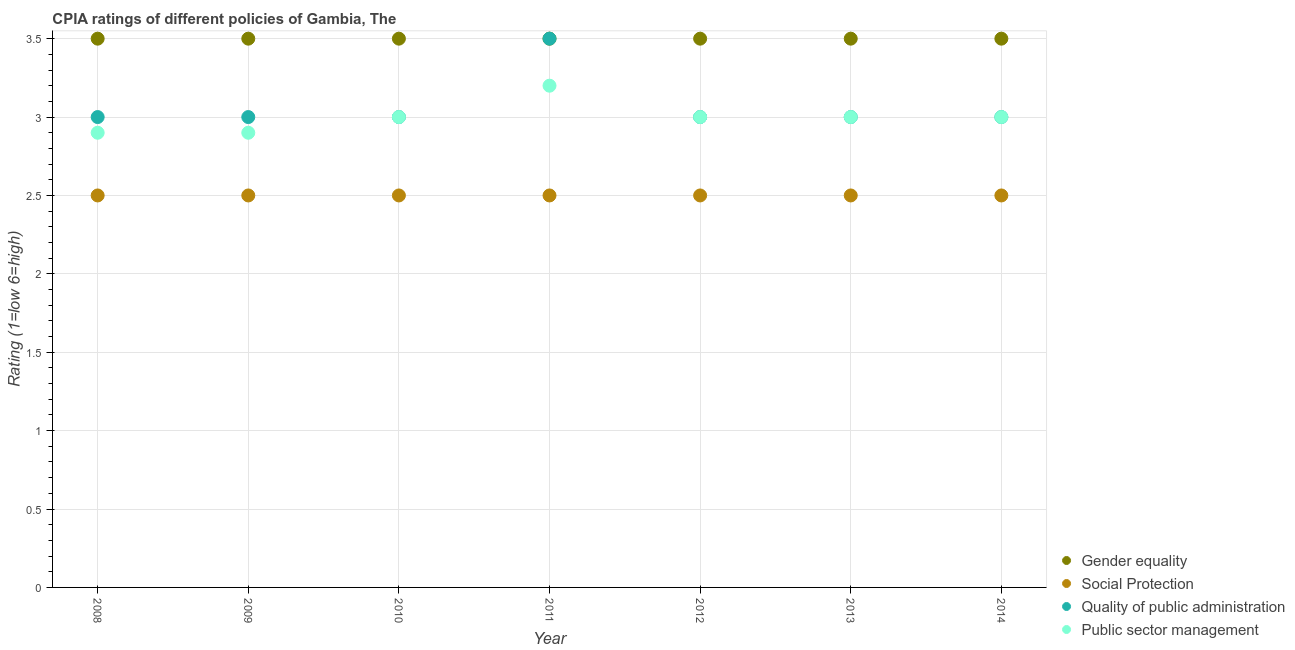How many different coloured dotlines are there?
Offer a terse response. 4. Across all years, what is the maximum cpia rating of gender equality?
Your response must be concise. 3.5. Across all years, what is the minimum cpia rating of public sector management?
Give a very brief answer. 2.9. In which year was the cpia rating of gender equality maximum?
Ensure brevity in your answer.  2008. In which year was the cpia rating of public sector management minimum?
Your response must be concise. 2008. What is the difference between the cpia rating of public sector management in 2012 and that in 2013?
Keep it short and to the point. 0. In how many years, is the cpia rating of quality of public administration greater than 2.7?
Your response must be concise. 7. Is the cpia rating of public sector management in 2010 less than that in 2014?
Offer a terse response. No. Is the difference between the cpia rating of social protection in 2008 and 2009 greater than the difference between the cpia rating of quality of public administration in 2008 and 2009?
Provide a short and direct response. No. What is the difference between the highest and the second highest cpia rating of gender equality?
Your answer should be compact. 0. What is the difference between the highest and the lowest cpia rating of quality of public administration?
Provide a succinct answer. 0.5. Is it the case that in every year, the sum of the cpia rating of social protection and cpia rating of quality of public administration is greater than the sum of cpia rating of gender equality and cpia rating of public sector management?
Make the answer very short. No. Is the cpia rating of public sector management strictly greater than the cpia rating of social protection over the years?
Your answer should be very brief. Yes. How many years are there in the graph?
Your response must be concise. 7. What is the difference between two consecutive major ticks on the Y-axis?
Your answer should be very brief. 0.5. Are the values on the major ticks of Y-axis written in scientific E-notation?
Your answer should be compact. No. Does the graph contain any zero values?
Keep it short and to the point. No. Where does the legend appear in the graph?
Your answer should be compact. Bottom right. How many legend labels are there?
Give a very brief answer. 4. What is the title of the graph?
Make the answer very short. CPIA ratings of different policies of Gambia, The. Does "Japan" appear as one of the legend labels in the graph?
Make the answer very short. No. What is the label or title of the X-axis?
Your answer should be compact. Year. What is the Rating (1=low 6=high) of Gender equality in 2008?
Provide a succinct answer. 3.5. What is the Rating (1=low 6=high) of Quality of public administration in 2008?
Your answer should be compact. 3. What is the Rating (1=low 6=high) of Social Protection in 2009?
Give a very brief answer. 2.5. What is the Rating (1=low 6=high) in Quality of public administration in 2009?
Offer a very short reply. 3. What is the Rating (1=low 6=high) of Public sector management in 2009?
Provide a succinct answer. 2.9. What is the Rating (1=low 6=high) in Social Protection in 2010?
Make the answer very short. 2.5. What is the Rating (1=low 6=high) of Quality of public administration in 2010?
Your answer should be very brief. 3. What is the Rating (1=low 6=high) of Social Protection in 2011?
Your answer should be very brief. 2.5. What is the Rating (1=low 6=high) of Public sector management in 2011?
Give a very brief answer. 3.2. What is the Rating (1=low 6=high) in Gender equality in 2012?
Keep it short and to the point. 3.5. What is the Rating (1=low 6=high) of Quality of public administration in 2012?
Offer a terse response. 3. What is the Rating (1=low 6=high) in Public sector management in 2012?
Make the answer very short. 3. What is the Rating (1=low 6=high) in Quality of public administration in 2013?
Provide a short and direct response. 3. What is the Rating (1=low 6=high) in Public sector management in 2014?
Make the answer very short. 3. Across all years, what is the maximum Rating (1=low 6=high) of Gender equality?
Make the answer very short. 3.5. Across all years, what is the maximum Rating (1=low 6=high) of Social Protection?
Make the answer very short. 2.5. Across all years, what is the maximum Rating (1=low 6=high) of Quality of public administration?
Make the answer very short. 3.5. Across all years, what is the maximum Rating (1=low 6=high) in Public sector management?
Make the answer very short. 3.2. Across all years, what is the minimum Rating (1=low 6=high) in Social Protection?
Make the answer very short. 2.5. Across all years, what is the minimum Rating (1=low 6=high) of Quality of public administration?
Ensure brevity in your answer.  3. Across all years, what is the minimum Rating (1=low 6=high) in Public sector management?
Keep it short and to the point. 2.9. What is the total Rating (1=low 6=high) in Gender equality in the graph?
Offer a very short reply. 24.5. What is the total Rating (1=low 6=high) in Social Protection in the graph?
Your response must be concise. 17.5. What is the total Rating (1=low 6=high) of Quality of public administration in the graph?
Offer a very short reply. 21.5. What is the total Rating (1=low 6=high) of Public sector management in the graph?
Your answer should be very brief. 21. What is the difference between the Rating (1=low 6=high) in Social Protection in 2008 and that in 2009?
Offer a very short reply. 0. What is the difference between the Rating (1=low 6=high) in Quality of public administration in 2008 and that in 2009?
Provide a short and direct response. 0. What is the difference between the Rating (1=low 6=high) in Public sector management in 2008 and that in 2009?
Offer a terse response. 0. What is the difference between the Rating (1=low 6=high) in Public sector management in 2008 and that in 2010?
Provide a succinct answer. -0.1. What is the difference between the Rating (1=low 6=high) of Social Protection in 2008 and that in 2011?
Make the answer very short. 0. What is the difference between the Rating (1=low 6=high) of Quality of public administration in 2008 and that in 2011?
Offer a terse response. -0.5. What is the difference between the Rating (1=low 6=high) of Gender equality in 2008 and that in 2012?
Ensure brevity in your answer.  0. What is the difference between the Rating (1=low 6=high) in Quality of public administration in 2008 and that in 2012?
Provide a short and direct response. 0. What is the difference between the Rating (1=low 6=high) of Public sector management in 2008 and that in 2012?
Ensure brevity in your answer.  -0.1. What is the difference between the Rating (1=low 6=high) in Gender equality in 2008 and that in 2013?
Provide a succinct answer. 0. What is the difference between the Rating (1=low 6=high) of Quality of public administration in 2008 and that in 2014?
Offer a terse response. 0. What is the difference between the Rating (1=low 6=high) in Public sector management in 2008 and that in 2014?
Keep it short and to the point. -0.1. What is the difference between the Rating (1=low 6=high) in Gender equality in 2009 and that in 2010?
Provide a succinct answer. 0. What is the difference between the Rating (1=low 6=high) in Social Protection in 2009 and that in 2011?
Keep it short and to the point. 0. What is the difference between the Rating (1=low 6=high) of Quality of public administration in 2009 and that in 2012?
Offer a terse response. 0. What is the difference between the Rating (1=low 6=high) of Public sector management in 2009 and that in 2012?
Your answer should be compact. -0.1. What is the difference between the Rating (1=low 6=high) in Gender equality in 2009 and that in 2013?
Give a very brief answer. 0. What is the difference between the Rating (1=low 6=high) in Quality of public administration in 2009 and that in 2013?
Your response must be concise. 0. What is the difference between the Rating (1=low 6=high) in Social Protection in 2009 and that in 2014?
Offer a terse response. 0. What is the difference between the Rating (1=low 6=high) of Quality of public administration in 2009 and that in 2014?
Offer a very short reply. 0. What is the difference between the Rating (1=low 6=high) of Social Protection in 2010 and that in 2011?
Keep it short and to the point. 0. What is the difference between the Rating (1=low 6=high) in Gender equality in 2010 and that in 2012?
Offer a terse response. 0. What is the difference between the Rating (1=low 6=high) of Gender equality in 2010 and that in 2013?
Provide a succinct answer. 0. What is the difference between the Rating (1=low 6=high) in Quality of public administration in 2010 and that in 2013?
Offer a very short reply. 0. What is the difference between the Rating (1=low 6=high) of Gender equality in 2010 and that in 2014?
Keep it short and to the point. 0. What is the difference between the Rating (1=low 6=high) in Social Protection in 2010 and that in 2014?
Ensure brevity in your answer.  0. What is the difference between the Rating (1=low 6=high) in Quality of public administration in 2010 and that in 2014?
Your answer should be compact. 0. What is the difference between the Rating (1=low 6=high) in Public sector management in 2010 and that in 2014?
Ensure brevity in your answer.  0. What is the difference between the Rating (1=low 6=high) of Gender equality in 2011 and that in 2012?
Give a very brief answer. 0. What is the difference between the Rating (1=low 6=high) in Quality of public administration in 2011 and that in 2012?
Your answer should be very brief. 0.5. What is the difference between the Rating (1=low 6=high) of Social Protection in 2011 and that in 2013?
Provide a succinct answer. 0. What is the difference between the Rating (1=low 6=high) of Quality of public administration in 2011 and that in 2013?
Offer a terse response. 0.5. What is the difference between the Rating (1=low 6=high) of Gender equality in 2011 and that in 2014?
Your answer should be compact. 0. What is the difference between the Rating (1=low 6=high) of Social Protection in 2011 and that in 2014?
Keep it short and to the point. 0. What is the difference between the Rating (1=low 6=high) of Public sector management in 2011 and that in 2014?
Your answer should be very brief. 0.2. What is the difference between the Rating (1=low 6=high) of Social Protection in 2012 and that in 2013?
Your answer should be very brief. 0. What is the difference between the Rating (1=low 6=high) in Gender equality in 2012 and that in 2014?
Your answer should be very brief. 0. What is the difference between the Rating (1=low 6=high) of Public sector management in 2012 and that in 2014?
Provide a short and direct response. 0. What is the difference between the Rating (1=low 6=high) in Public sector management in 2013 and that in 2014?
Your response must be concise. 0. What is the difference between the Rating (1=low 6=high) in Gender equality in 2008 and the Rating (1=low 6=high) in Social Protection in 2009?
Make the answer very short. 1. What is the difference between the Rating (1=low 6=high) in Gender equality in 2008 and the Rating (1=low 6=high) in Public sector management in 2009?
Ensure brevity in your answer.  0.6. What is the difference between the Rating (1=low 6=high) of Social Protection in 2008 and the Rating (1=low 6=high) of Public sector management in 2009?
Give a very brief answer. -0.4. What is the difference between the Rating (1=low 6=high) in Gender equality in 2008 and the Rating (1=low 6=high) in Public sector management in 2010?
Offer a very short reply. 0.5. What is the difference between the Rating (1=low 6=high) of Social Protection in 2008 and the Rating (1=low 6=high) of Quality of public administration in 2010?
Your response must be concise. -0.5. What is the difference between the Rating (1=low 6=high) of Gender equality in 2008 and the Rating (1=low 6=high) of Social Protection in 2011?
Your answer should be very brief. 1. What is the difference between the Rating (1=low 6=high) of Gender equality in 2008 and the Rating (1=low 6=high) of Quality of public administration in 2011?
Provide a short and direct response. 0. What is the difference between the Rating (1=low 6=high) of Social Protection in 2008 and the Rating (1=low 6=high) of Quality of public administration in 2011?
Offer a very short reply. -1. What is the difference between the Rating (1=low 6=high) of Quality of public administration in 2008 and the Rating (1=low 6=high) of Public sector management in 2011?
Offer a terse response. -0.2. What is the difference between the Rating (1=low 6=high) of Gender equality in 2008 and the Rating (1=low 6=high) of Quality of public administration in 2012?
Give a very brief answer. 0.5. What is the difference between the Rating (1=low 6=high) in Social Protection in 2008 and the Rating (1=low 6=high) in Quality of public administration in 2012?
Make the answer very short. -0.5. What is the difference between the Rating (1=low 6=high) in Gender equality in 2008 and the Rating (1=low 6=high) in Social Protection in 2013?
Your response must be concise. 1. What is the difference between the Rating (1=low 6=high) in Social Protection in 2008 and the Rating (1=low 6=high) in Public sector management in 2013?
Give a very brief answer. -0.5. What is the difference between the Rating (1=low 6=high) in Quality of public administration in 2008 and the Rating (1=low 6=high) in Public sector management in 2013?
Your response must be concise. 0. What is the difference between the Rating (1=low 6=high) of Gender equality in 2008 and the Rating (1=low 6=high) of Social Protection in 2014?
Your answer should be very brief. 1. What is the difference between the Rating (1=low 6=high) in Quality of public administration in 2008 and the Rating (1=low 6=high) in Public sector management in 2014?
Make the answer very short. 0. What is the difference between the Rating (1=low 6=high) of Gender equality in 2009 and the Rating (1=low 6=high) of Social Protection in 2010?
Provide a succinct answer. 1. What is the difference between the Rating (1=low 6=high) of Gender equality in 2009 and the Rating (1=low 6=high) of Public sector management in 2010?
Provide a succinct answer. 0.5. What is the difference between the Rating (1=low 6=high) of Social Protection in 2009 and the Rating (1=low 6=high) of Quality of public administration in 2010?
Offer a terse response. -0.5. What is the difference between the Rating (1=low 6=high) in Quality of public administration in 2009 and the Rating (1=low 6=high) in Public sector management in 2010?
Your answer should be very brief. 0. What is the difference between the Rating (1=low 6=high) in Gender equality in 2009 and the Rating (1=low 6=high) in Quality of public administration in 2011?
Make the answer very short. 0. What is the difference between the Rating (1=low 6=high) in Social Protection in 2009 and the Rating (1=low 6=high) in Public sector management in 2011?
Provide a succinct answer. -0.7. What is the difference between the Rating (1=low 6=high) in Gender equality in 2009 and the Rating (1=low 6=high) in Social Protection in 2012?
Your response must be concise. 1. What is the difference between the Rating (1=low 6=high) of Gender equality in 2009 and the Rating (1=low 6=high) of Quality of public administration in 2012?
Your answer should be very brief. 0.5. What is the difference between the Rating (1=low 6=high) of Social Protection in 2009 and the Rating (1=low 6=high) of Quality of public administration in 2012?
Ensure brevity in your answer.  -0.5. What is the difference between the Rating (1=low 6=high) in Gender equality in 2009 and the Rating (1=low 6=high) in Quality of public administration in 2013?
Make the answer very short. 0.5. What is the difference between the Rating (1=low 6=high) in Gender equality in 2009 and the Rating (1=low 6=high) in Public sector management in 2013?
Provide a succinct answer. 0.5. What is the difference between the Rating (1=low 6=high) in Social Protection in 2009 and the Rating (1=low 6=high) in Quality of public administration in 2013?
Make the answer very short. -0.5. What is the difference between the Rating (1=low 6=high) of Social Protection in 2009 and the Rating (1=low 6=high) of Public sector management in 2013?
Ensure brevity in your answer.  -0.5. What is the difference between the Rating (1=low 6=high) of Gender equality in 2009 and the Rating (1=low 6=high) of Quality of public administration in 2014?
Give a very brief answer. 0.5. What is the difference between the Rating (1=low 6=high) in Gender equality in 2009 and the Rating (1=low 6=high) in Public sector management in 2014?
Your answer should be compact. 0.5. What is the difference between the Rating (1=low 6=high) of Social Protection in 2009 and the Rating (1=low 6=high) of Quality of public administration in 2014?
Offer a terse response. -0.5. What is the difference between the Rating (1=low 6=high) of Quality of public administration in 2009 and the Rating (1=low 6=high) of Public sector management in 2014?
Your response must be concise. 0. What is the difference between the Rating (1=low 6=high) of Gender equality in 2010 and the Rating (1=low 6=high) of Social Protection in 2011?
Provide a short and direct response. 1. What is the difference between the Rating (1=low 6=high) in Gender equality in 2010 and the Rating (1=low 6=high) in Public sector management in 2011?
Offer a very short reply. 0.3. What is the difference between the Rating (1=low 6=high) of Social Protection in 2010 and the Rating (1=low 6=high) of Quality of public administration in 2011?
Offer a very short reply. -1. What is the difference between the Rating (1=low 6=high) of Social Protection in 2010 and the Rating (1=low 6=high) of Public sector management in 2011?
Provide a succinct answer. -0.7. What is the difference between the Rating (1=low 6=high) in Gender equality in 2010 and the Rating (1=low 6=high) in Social Protection in 2012?
Offer a terse response. 1. What is the difference between the Rating (1=low 6=high) in Gender equality in 2010 and the Rating (1=low 6=high) in Public sector management in 2012?
Keep it short and to the point. 0.5. What is the difference between the Rating (1=low 6=high) in Social Protection in 2010 and the Rating (1=low 6=high) in Public sector management in 2012?
Give a very brief answer. -0.5. What is the difference between the Rating (1=low 6=high) of Social Protection in 2010 and the Rating (1=low 6=high) of Quality of public administration in 2013?
Provide a short and direct response. -0.5. What is the difference between the Rating (1=low 6=high) of Quality of public administration in 2010 and the Rating (1=low 6=high) of Public sector management in 2013?
Your answer should be very brief. 0. What is the difference between the Rating (1=low 6=high) of Gender equality in 2010 and the Rating (1=low 6=high) of Quality of public administration in 2014?
Keep it short and to the point. 0.5. What is the difference between the Rating (1=low 6=high) of Gender equality in 2010 and the Rating (1=low 6=high) of Public sector management in 2014?
Give a very brief answer. 0.5. What is the difference between the Rating (1=low 6=high) of Social Protection in 2010 and the Rating (1=low 6=high) of Public sector management in 2014?
Provide a short and direct response. -0.5. What is the difference between the Rating (1=low 6=high) of Gender equality in 2011 and the Rating (1=low 6=high) of Social Protection in 2012?
Your answer should be compact. 1. What is the difference between the Rating (1=low 6=high) in Social Protection in 2011 and the Rating (1=low 6=high) in Public sector management in 2012?
Give a very brief answer. -0.5. What is the difference between the Rating (1=low 6=high) of Quality of public administration in 2011 and the Rating (1=low 6=high) of Public sector management in 2012?
Ensure brevity in your answer.  0.5. What is the difference between the Rating (1=low 6=high) in Gender equality in 2011 and the Rating (1=low 6=high) in Quality of public administration in 2013?
Provide a short and direct response. 0.5. What is the difference between the Rating (1=low 6=high) in Social Protection in 2011 and the Rating (1=low 6=high) in Quality of public administration in 2013?
Your answer should be compact. -0.5. What is the difference between the Rating (1=low 6=high) of Social Protection in 2011 and the Rating (1=low 6=high) of Public sector management in 2013?
Your answer should be compact. -0.5. What is the difference between the Rating (1=low 6=high) of Gender equality in 2011 and the Rating (1=low 6=high) of Social Protection in 2014?
Offer a terse response. 1. What is the difference between the Rating (1=low 6=high) of Social Protection in 2011 and the Rating (1=low 6=high) of Quality of public administration in 2014?
Ensure brevity in your answer.  -0.5. What is the difference between the Rating (1=low 6=high) in Gender equality in 2012 and the Rating (1=low 6=high) in Quality of public administration in 2013?
Your answer should be very brief. 0.5. What is the difference between the Rating (1=low 6=high) of Social Protection in 2012 and the Rating (1=low 6=high) of Quality of public administration in 2013?
Your response must be concise. -0.5. What is the difference between the Rating (1=low 6=high) of Gender equality in 2012 and the Rating (1=low 6=high) of Social Protection in 2014?
Your answer should be compact. 1. What is the difference between the Rating (1=low 6=high) in Social Protection in 2012 and the Rating (1=low 6=high) in Public sector management in 2014?
Ensure brevity in your answer.  -0.5. What is the difference between the Rating (1=low 6=high) in Quality of public administration in 2012 and the Rating (1=low 6=high) in Public sector management in 2014?
Make the answer very short. 0. What is the difference between the Rating (1=low 6=high) in Gender equality in 2013 and the Rating (1=low 6=high) in Social Protection in 2014?
Provide a succinct answer. 1. What is the difference between the Rating (1=low 6=high) in Social Protection in 2013 and the Rating (1=low 6=high) in Quality of public administration in 2014?
Provide a succinct answer. -0.5. What is the average Rating (1=low 6=high) of Gender equality per year?
Your response must be concise. 3.5. What is the average Rating (1=low 6=high) of Social Protection per year?
Offer a terse response. 2.5. What is the average Rating (1=low 6=high) in Quality of public administration per year?
Keep it short and to the point. 3.07. In the year 2008, what is the difference between the Rating (1=low 6=high) of Gender equality and Rating (1=low 6=high) of Social Protection?
Provide a succinct answer. 1. In the year 2008, what is the difference between the Rating (1=low 6=high) in Gender equality and Rating (1=low 6=high) in Public sector management?
Ensure brevity in your answer.  0.6. In the year 2008, what is the difference between the Rating (1=low 6=high) in Social Protection and Rating (1=low 6=high) in Quality of public administration?
Your answer should be compact. -0.5. In the year 2008, what is the difference between the Rating (1=low 6=high) in Social Protection and Rating (1=low 6=high) in Public sector management?
Give a very brief answer. -0.4. In the year 2009, what is the difference between the Rating (1=low 6=high) in Gender equality and Rating (1=low 6=high) in Public sector management?
Provide a short and direct response. 0.6. In the year 2009, what is the difference between the Rating (1=low 6=high) in Social Protection and Rating (1=low 6=high) in Quality of public administration?
Give a very brief answer. -0.5. In the year 2009, what is the difference between the Rating (1=low 6=high) of Social Protection and Rating (1=low 6=high) of Public sector management?
Offer a very short reply. -0.4. In the year 2009, what is the difference between the Rating (1=low 6=high) in Quality of public administration and Rating (1=low 6=high) in Public sector management?
Ensure brevity in your answer.  0.1. In the year 2010, what is the difference between the Rating (1=low 6=high) in Gender equality and Rating (1=low 6=high) in Public sector management?
Your answer should be compact. 0.5. In the year 2010, what is the difference between the Rating (1=low 6=high) in Social Protection and Rating (1=low 6=high) in Quality of public administration?
Keep it short and to the point. -0.5. In the year 2010, what is the difference between the Rating (1=low 6=high) in Quality of public administration and Rating (1=low 6=high) in Public sector management?
Make the answer very short. 0. In the year 2011, what is the difference between the Rating (1=low 6=high) of Gender equality and Rating (1=low 6=high) of Public sector management?
Provide a short and direct response. 0.3. In the year 2011, what is the difference between the Rating (1=low 6=high) of Quality of public administration and Rating (1=low 6=high) of Public sector management?
Provide a succinct answer. 0.3. In the year 2012, what is the difference between the Rating (1=low 6=high) in Gender equality and Rating (1=low 6=high) in Quality of public administration?
Your answer should be compact. 0.5. In the year 2012, what is the difference between the Rating (1=low 6=high) in Gender equality and Rating (1=low 6=high) in Public sector management?
Offer a very short reply. 0.5. In the year 2013, what is the difference between the Rating (1=low 6=high) in Gender equality and Rating (1=low 6=high) in Quality of public administration?
Provide a short and direct response. 0.5. In the year 2013, what is the difference between the Rating (1=low 6=high) in Gender equality and Rating (1=low 6=high) in Public sector management?
Give a very brief answer. 0.5. In the year 2013, what is the difference between the Rating (1=low 6=high) in Social Protection and Rating (1=low 6=high) in Public sector management?
Make the answer very short. -0.5. In the year 2014, what is the difference between the Rating (1=low 6=high) of Gender equality and Rating (1=low 6=high) of Public sector management?
Offer a very short reply. 0.5. In the year 2014, what is the difference between the Rating (1=low 6=high) of Social Protection and Rating (1=low 6=high) of Public sector management?
Your answer should be compact. -0.5. What is the ratio of the Rating (1=low 6=high) in Social Protection in 2008 to that in 2009?
Keep it short and to the point. 1. What is the ratio of the Rating (1=low 6=high) of Public sector management in 2008 to that in 2009?
Make the answer very short. 1. What is the ratio of the Rating (1=low 6=high) of Gender equality in 2008 to that in 2010?
Ensure brevity in your answer.  1. What is the ratio of the Rating (1=low 6=high) in Social Protection in 2008 to that in 2010?
Ensure brevity in your answer.  1. What is the ratio of the Rating (1=low 6=high) of Public sector management in 2008 to that in 2010?
Your response must be concise. 0.97. What is the ratio of the Rating (1=low 6=high) of Gender equality in 2008 to that in 2011?
Your answer should be very brief. 1. What is the ratio of the Rating (1=low 6=high) in Public sector management in 2008 to that in 2011?
Provide a succinct answer. 0.91. What is the ratio of the Rating (1=low 6=high) in Gender equality in 2008 to that in 2012?
Ensure brevity in your answer.  1. What is the ratio of the Rating (1=low 6=high) in Public sector management in 2008 to that in 2012?
Make the answer very short. 0.97. What is the ratio of the Rating (1=low 6=high) of Gender equality in 2008 to that in 2013?
Your response must be concise. 1. What is the ratio of the Rating (1=low 6=high) of Social Protection in 2008 to that in 2013?
Your answer should be very brief. 1. What is the ratio of the Rating (1=low 6=high) of Quality of public administration in 2008 to that in 2013?
Your answer should be compact. 1. What is the ratio of the Rating (1=low 6=high) in Public sector management in 2008 to that in 2013?
Give a very brief answer. 0.97. What is the ratio of the Rating (1=low 6=high) of Social Protection in 2008 to that in 2014?
Provide a succinct answer. 1. What is the ratio of the Rating (1=low 6=high) in Quality of public administration in 2008 to that in 2014?
Provide a succinct answer. 1. What is the ratio of the Rating (1=low 6=high) in Public sector management in 2008 to that in 2014?
Give a very brief answer. 0.97. What is the ratio of the Rating (1=low 6=high) of Gender equality in 2009 to that in 2010?
Provide a succinct answer. 1. What is the ratio of the Rating (1=low 6=high) in Quality of public administration in 2009 to that in 2010?
Keep it short and to the point. 1. What is the ratio of the Rating (1=low 6=high) in Public sector management in 2009 to that in 2010?
Provide a short and direct response. 0.97. What is the ratio of the Rating (1=low 6=high) of Social Protection in 2009 to that in 2011?
Offer a terse response. 1. What is the ratio of the Rating (1=low 6=high) of Public sector management in 2009 to that in 2011?
Provide a short and direct response. 0.91. What is the ratio of the Rating (1=low 6=high) in Social Protection in 2009 to that in 2012?
Provide a short and direct response. 1. What is the ratio of the Rating (1=low 6=high) of Quality of public administration in 2009 to that in 2012?
Make the answer very short. 1. What is the ratio of the Rating (1=low 6=high) in Public sector management in 2009 to that in 2012?
Offer a terse response. 0.97. What is the ratio of the Rating (1=low 6=high) of Gender equality in 2009 to that in 2013?
Your answer should be compact. 1. What is the ratio of the Rating (1=low 6=high) of Social Protection in 2009 to that in 2013?
Provide a succinct answer. 1. What is the ratio of the Rating (1=low 6=high) of Public sector management in 2009 to that in 2013?
Provide a short and direct response. 0.97. What is the ratio of the Rating (1=low 6=high) in Gender equality in 2009 to that in 2014?
Offer a terse response. 1. What is the ratio of the Rating (1=low 6=high) of Quality of public administration in 2009 to that in 2014?
Ensure brevity in your answer.  1. What is the ratio of the Rating (1=low 6=high) of Public sector management in 2009 to that in 2014?
Keep it short and to the point. 0.97. What is the ratio of the Rating (1=low 6=high) in Gender equality in 2010 to that in 2011?
Offer a very short reply. 1. What is the ratio of the Rating (1=low 6=high) in Social Protection in 2010 to that in 2011?
Your answer should be very brief. 1. What is the ratio of the Rating (1=low 6=high) in Quality of public administration in 2010 to that in 2011?
Give a very brief answer. 0.86. What is the ratio of the Rating (1=low 6=high) in Quality of public administration in 2010 to that in 2012?
Give a very brief answer. 1. What is the ratio of the Rating (1=low 6=high) of Gender equality in 2010 to that in 2013?
Offer a very short reply. 1. What is the ratio of the Rating (1=low 6=high) of Social Protection in 2010 to that in 2013?
Make the answer very short. 1. What is the ratio of the Rating (1=low 6=high) in Public sector management in 2010 to that in 2013?
Offer a very short reply. 1. What is the ratio of the Rating (1=low 6=high) in Public sector management in 2010 to that in 2014?
Your answer should be very brief. 1. What is the ratio of the Rating (1=low 6=high) of Gender equality in 2011 to that in 2012?
Provide a short and direct response. 1. What is the ratio of the Rating (1=low 6=high) of Social Protection in 2011 to that in 2012?
Your response must be concise. 1. What is the ratio of the Rating (1=low 6=high) in Quality of public administration in 2011 to that in 2012?
Your response must be concise. 1.17. What is the ratio of the Rating (1=low 6=high) in Public sector management in 2011 to that in 2012?
Offer a terse response. 1.07. What is the ratio of the Rating (1=low 6=high) of Gender equality in 2011 to that in 2013?
Ensure brevity in your answer.  1. What is the ratio of the Rating (1=low 6=high) of Social Protection in 2011 to that in 2013?
Offer a very short reply. 1. What is the ratio of the Rating (1=low 6=high) in Quality of public administration in 2011 to that in 2013?
Provide a short and direct response. 1.17. What is the ratio of the Rating (1=low 6=high) in Public sector management in 2011 to that in 2013?
Provide a succinct answer. 1.07. What is the ratio of the Rating (1=low 6=high) of Gender equality in 2011 to that in 2014?
Provide a short and direct response. 1. What is the ratio of the Rating (1=low 6=high) of Social Protection in 2011 to that in 2014?
Offer a very short reply. 1. What is the ratio of the Rating (1=low 6=high) of Quality of public administration in 2011 to that in 2014?
Your answer should be compact. 1.17. What is the ratio of the Rating (1=low 6=high) of Public sector management in 2011 to that in 2014?
Ensure brevity in your answer.  1.07. What is the ratio of the Rating (1=low 6=high) in Gender equality in 2012 to that in 2013?
Your answer should be compact. 1. What is the ratio of the Rating (1=low 6=high) of Social Protection in 2012 to that in 2013?
Ensure brevity in your answer.  1. What is the ratio of the Rating (1=low 6=high) of Quality of public administration in 2012 to that in 2013?
Give a very brief answer. 1. What is the ratio of the Rating (1=low 6=high) of Public sector management in 2012 to that in 2013?
Give a very brief answer. 1. What is the ratio of the Rating (1=low 6=high) of Gender equality in 2012 to that in 2014?
Offer a terse response. 1. What is the ratio of the Rating (1=low 6=high) of Quality of public administration in 2012 to that in 2014?
Provide a short and direct response. 1. What is the ratio of the Rating (1=low 6=high) in Public sector management in 2012 to that in 2014?
Ensure brevity in your answer.  1. What is the ratio of the Rating (1=low 6=high) of Social Protection in 2013 to that in 2014?
Offer a terse response. 1. What is the ratio of the Rating (1=low 6=high) of Public sector management in 2013 to that in 2014?
Provide a short and direct response. 1. What is the difference between the highest and the second highest Rating (1=low 6=high) in Gender equality?
Offer a terse response. 0. What is the difference between the highest and the lowest Rating (1=low 6=high) of Gender equality?
Your answer should be compact. 0. What is the difference between the highest and the lowest Rating (1=low 6=high) in Social Protection?
Ensure brevity in your answer.  0. What is the difference between the highest and the lowest Rating (1=low 6=high) of Quality of public administration?
Provide a short and direct response. 0.5. What is the difference between the highest and the lowest Rating (1=low 6=high) of Public sector management?
Your response must be concise. 0.3. 